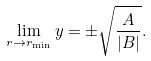<formula> <loc_0><loc_0><loc_500><loc_500>\lim _ { r \rightarrow r _ { \min } } y = \pm \sqrt { \frac { A } { | B | } } .</formula> 